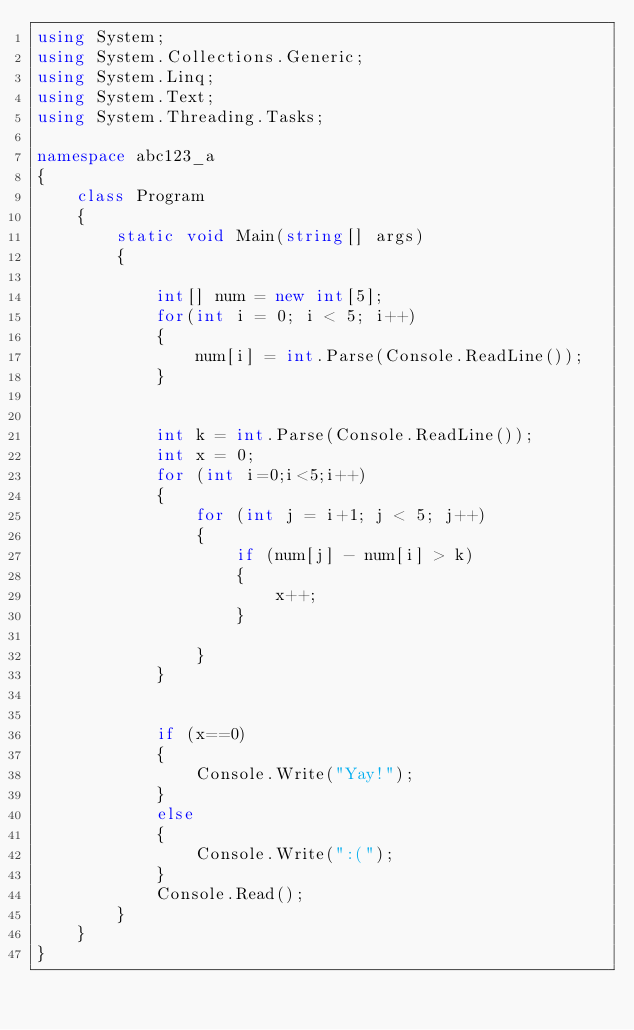Convert code to text. <code><loc_0><loc_0><loc_500><loc_500><_C#_>using System;
using System.Collections.Generic;
using System.Linq;
using System.Text;
using System.Threading.Tasks;

namespace abc123_a
{
    class Program
    {
        static void Main(string[] args)
        {           
           
            int[] num = new int[5];
            for(int i = 0; i < 5; i++)
            {
                num[i] = int.Parse(Console.ReadLine());
            }


            int k = int.Parse(Console.ReadLine());
            int x = 0;
            for (int i=0;i<5;i++)
            {
                for (int j = i+1; j < 5; j++)
                {
                    if (num[j] - num[i] > k)
                    {
                        x++;
                    }
                       
                }
            }


            if (x==0)
            {
                Console.Write("Yay!");
            }
            else
            {
                Console.Write(":(");
            }
            Console.Read();
        }
    }
}
</code> 